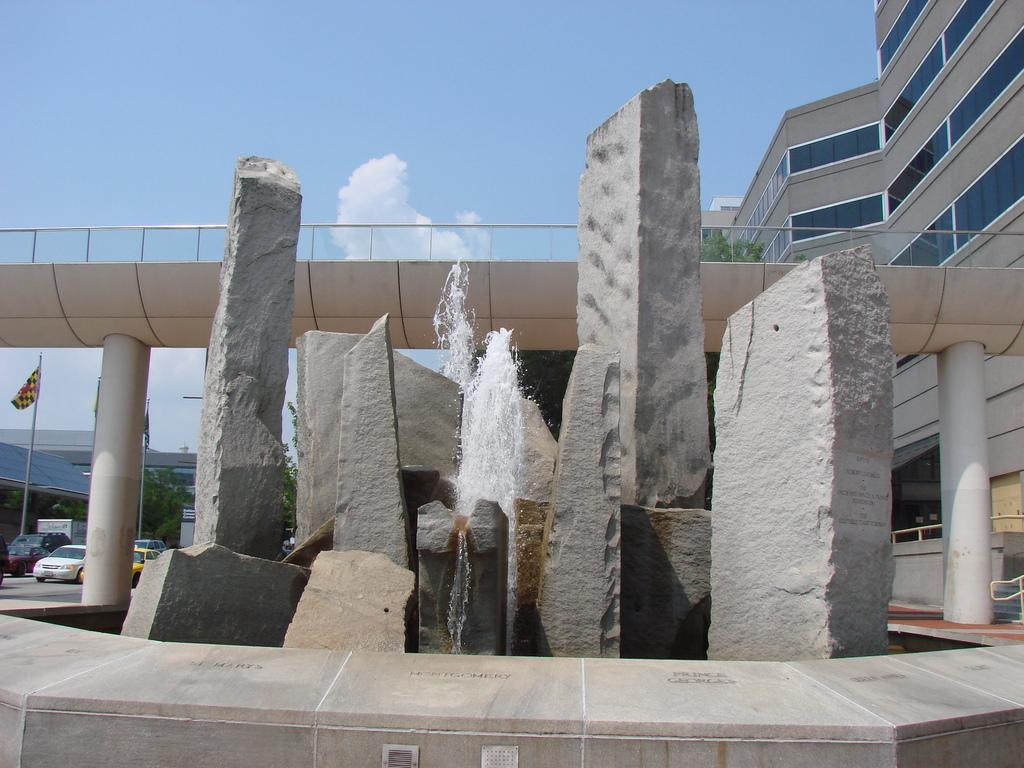What type of natural elements can be seen in the image? There are rocks in the image. What is located in the middle of the image? There is a fountain in the middle of the image. What can be seen in the background of the image? There is a gray-colored building, vehicles, and a flag in the background. What is the color of the sky in the image? The sky is blue and white in color. What type of pie is being served at the church in the image? There is no pie or church present in the image. Can you provide me with a copy of the receipt for the items purchased in the image? There is no receipt present in the image, as it is a photograph of a scene and not a transaction. 